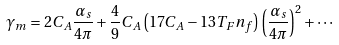<formula> <loc_0><loc_0><loc_500><loc_500>\gamma _ { m } = 2 C _ { A } \frac { \alpha _ { s } } { 4 \pi } + \frac { 4 } { 9 } C _ { A } \left ( 1 7 C _ { A } - 1 3 T _ { F } n _ { f } \right ) \left ( \frac { \alpha _ { s } } { 4 \pi } \right ) ^ { 2 } + \cdots</formula> 